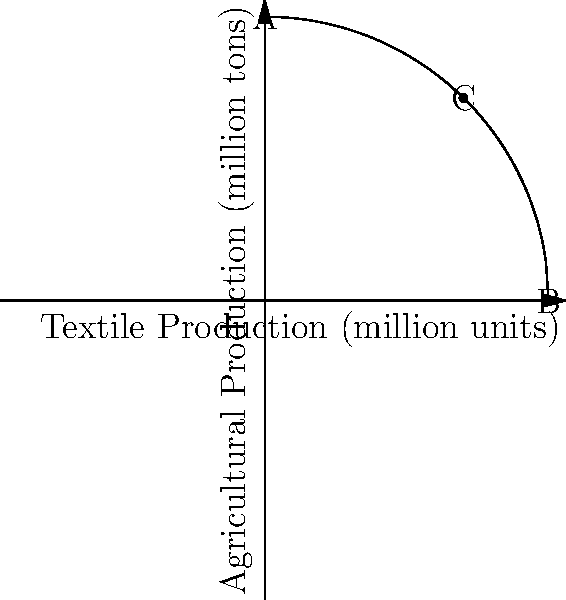The production possibility frontier (PPF) for Pakistan's textile and agriculture industries is shown above. If the country is currently producing at point C (7 million units of textiles, 7.14 million tons of agricultural products), what is the opportunity cost of increasing textile production by 1 million units? To find the opportunity cost of increasing textile production, we need to follow these steps:

1) Identify the current production point: C (7, 7.14)

2) Find the new production point after increasing textile production by 1 million units:
   New x-coordinate = 7 + 1 = 8 million units of textiles

3) Calculate the y-coordinate (agricultural production) at x = 8:
   $y = \sqrt{100 - x^2} = \sqrt{100 - 8^2} = \sqrt{36} = 6$ million tons

4) The new point is (8, 6)

5) Calculate the change in agricultural production:
   $\Delta y = 6 - 7.14 = -1.14$ million tons

6) The opportunity cost is the absolute value of this change:
   Opportunity cost = $|1.14|$ = 1.14 million tons of agricultural products

Therefore, to increase textile production by 1 million units, Pakistan would need to decrease agricultural production by 1.14 million tons.
Answer: 1.14 million tons of agricultural products 